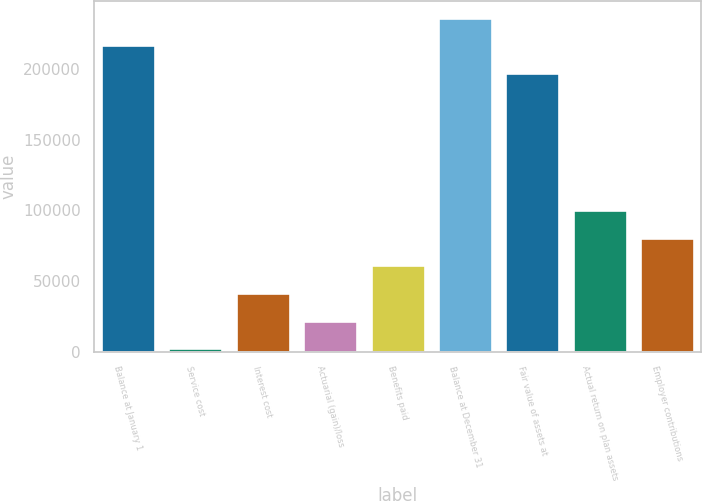Convert chart to OTSL. <chart><loc_0><loc_0><loc_500><loc_500><bar_chart><fcel>Balance at January 1<fcel>Service cost<fcel>Interest cost<fcel>Actuarial (gain)/loss<fcel>Benefits paid<fcel>Balance at December 31<fcel>Fair value of assets at<fcel>Actual return on plan assets<fcel>Employer contributions<nl><fcel>216948<fcel>2625<fcel>41592.8<fcel>22108.9<fcel>61076.7<fcel>236432<fcel>197464<fcel>100044<fcel>80560.6<nl></chart> 